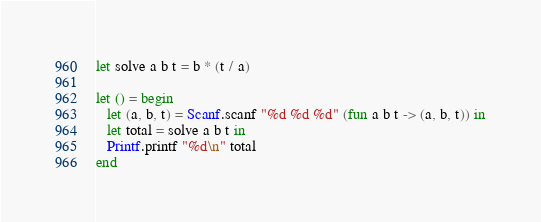Convert code to text. <code><loc_0><loc_0><loc_500><loc_500><_OCaml_>let solve a b t = b * (t / a)

let () = begin
   let (a, b, t) = Scanf.scanf "%d %d %d" (fun a b t -> (a, b, t)) in
   let total = solve a b t in
   Printf.printf "%d\n" total
end</code> 